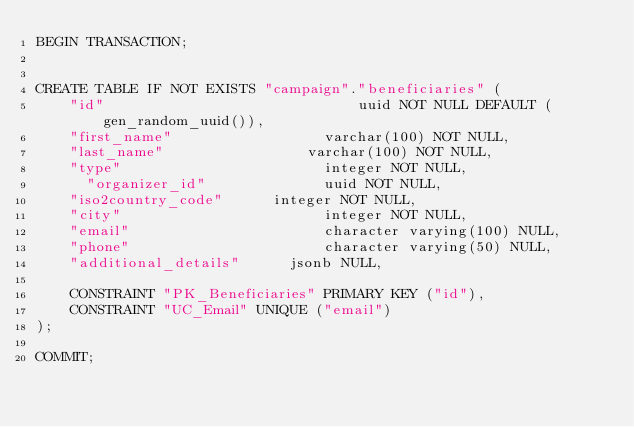Convert code to text. <code><loc_0><loc_0><loc_500><loc_500><_SQL_>BEGIN TRANSACTION;


CREATE TABLE IF NOT EXISTS "campaign"."beneficiaries" (
    "id"					          uuid NOT NULL DEFAULT (gen_random_uuid()),
    "first_name"			      varchar(100) NOT NULL,
    "last_name"			        varchar(100) NOT NULL,
    "type"				          integer NOT NULL,
	  "organizer_id"		      uuid NOT NULL,
    "iso2country_code"	    integer NOT NULL,
    "city"				          integer NOT NULL,
    "email"				          character varying(100) NULL,
    "phone"				          character varying(50) NULL,
    "additional_details"	  jsonb NULL,

    CONSTRAINT "PK_Beneficiaries" PRIMARY KEY ("id"),
    CONSTRAINT "UC_Email" UNIQUE ("email")
);

COMMIT;
</code> 